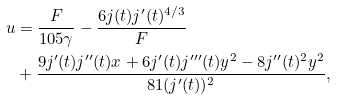<formula> <loc_0><loc_0><loc_500><loc_500>u & = \frac { F } { 1 0 5 \gamma } - \frac { 6 j ( t ) j ^ { \prime } ( t ) ^ { 4 / 3 } } { F } \\ & + \frac { 9 j ^ { \prime } ( t ) j ^ { \prime \prime } ( t ) x + 6 j ^ { \prime } ( t ) j ^ { \prime \prime \prime } ( t ) y ^ { 2 } - 8 j ^ { \prime \prime } ( t ) ^ { 2 } y ^ { 2 } } { 8 1 ( j ^ { \prime } ( t ) ) ^ { 2 } } ,</formula> 